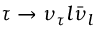<formula> <loc_0><loc_0><loc_500><loc_500>\tau \to \nu _ { \tau } l \bar { \nu } _ { l }</formula> 